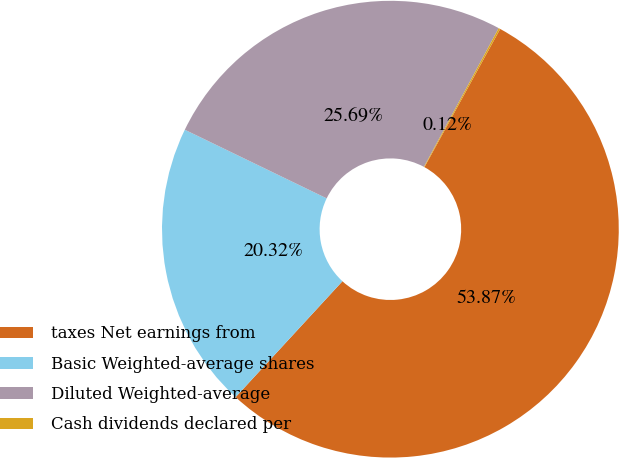<chart> <loc_0><loc_0><loc_500><loc_500><pie_chart><fcel>taxes Net earnings from<fcel>Basic Weighted-average shares<fcel>Diluted Weighted-average<fcel>Cash dividends declared per<nl><fcel>53.87%<fcel>20.32%<fcel>25.69%<fcel>0.12%<nl></chart> 